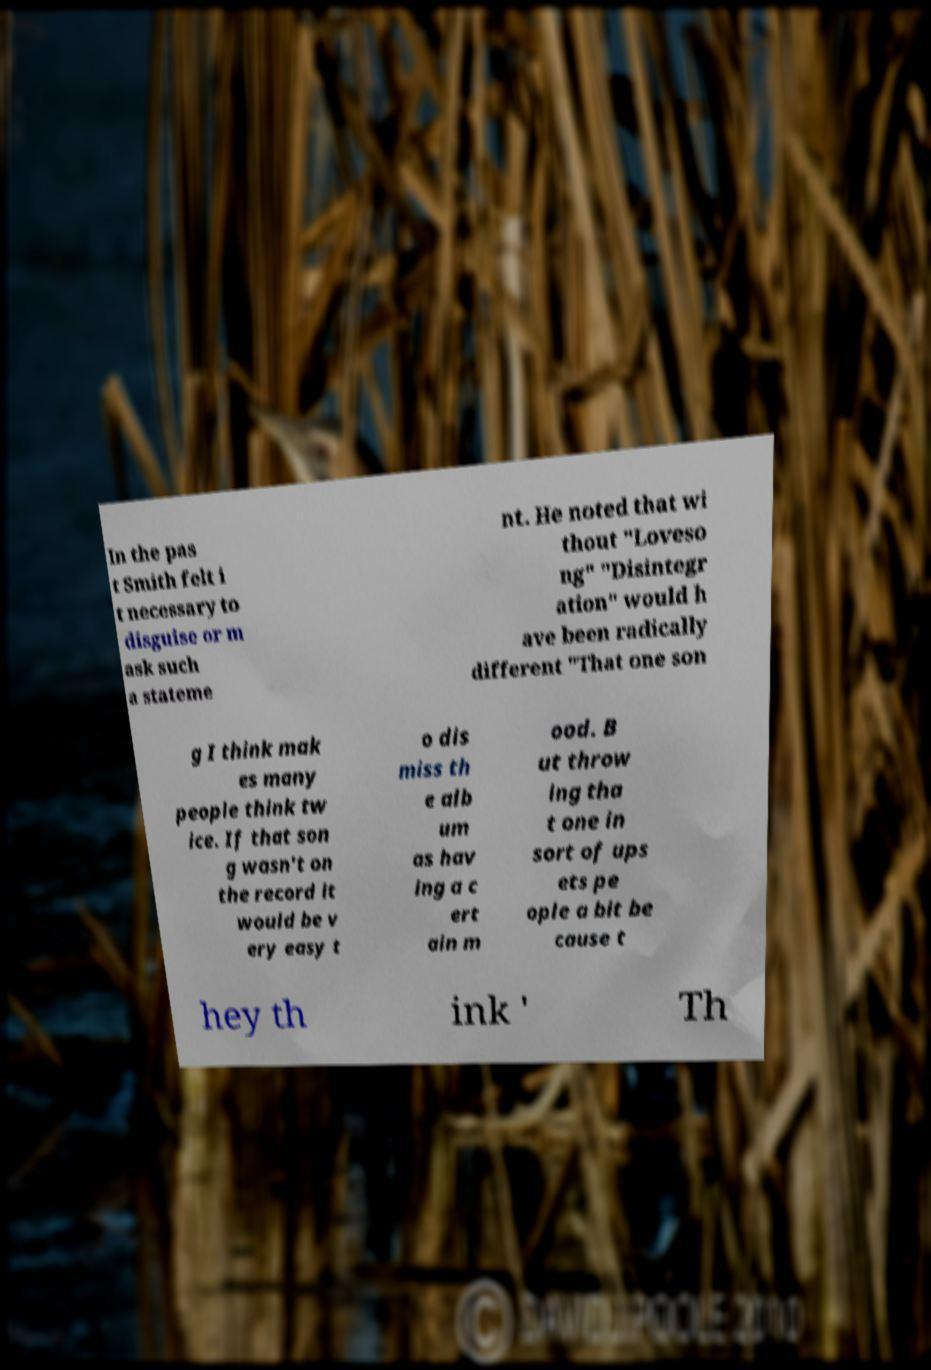What messages or text are displayed in this image? I need them in a readable, typed format. In the pas t Smith felt i t necessary to disguise or m ask such a stateme nt. He noted that wi thout "Loveso ng" "Disintegr ation" would h ave been radically different "That one son g I think mak es many people think tw ice. If that son g wasn't on the record it would be v ery easy t o dis miss th e alb um as hav ing a c ert ain m ood. B ut throw ing tha t one in sort of ups ets pe ople a bit be cause t hey th ink ' Th 